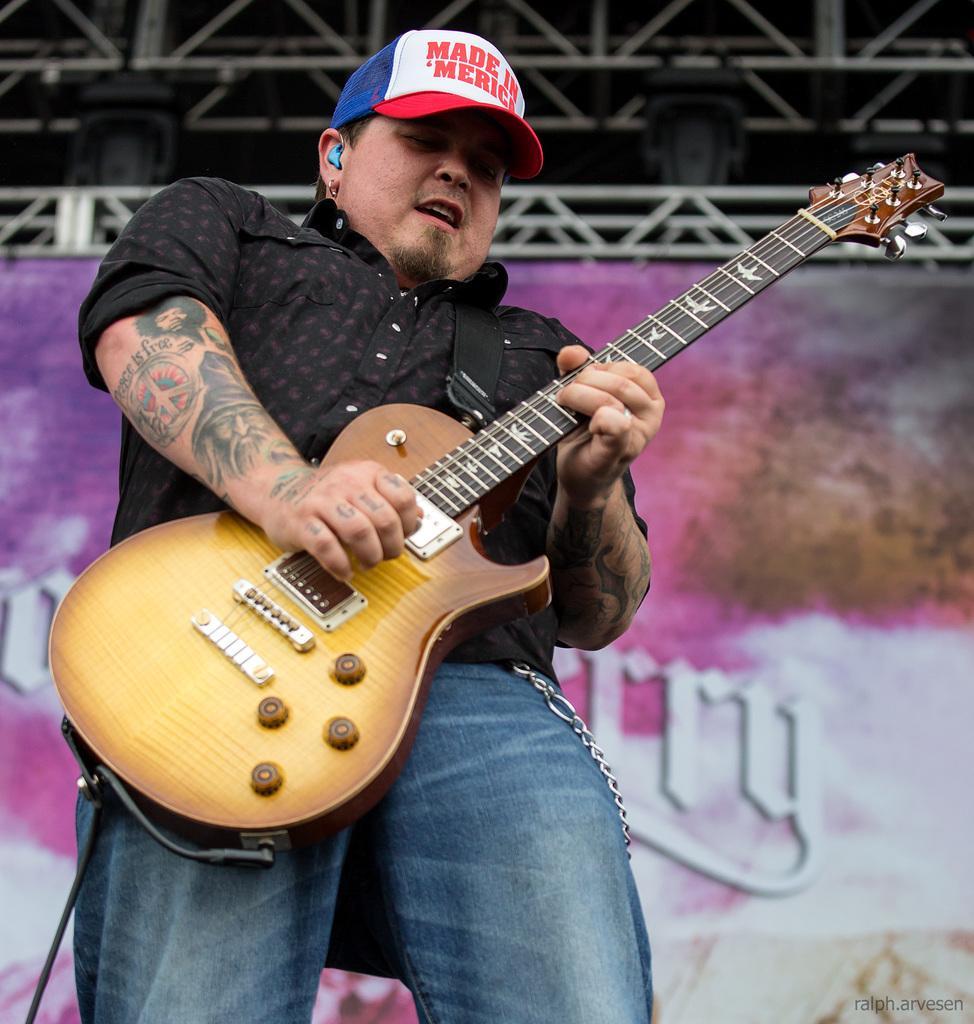Can you describe this image briefly? In the image we can see there is a man who is holding a guitar in his hand. 